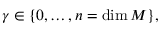Convert formula to latex. <formula><loc_0><loc_0><loc_500><loc_500>\gamma \in \{ 0 , \dots , n = \dim M \} ,</formula> 